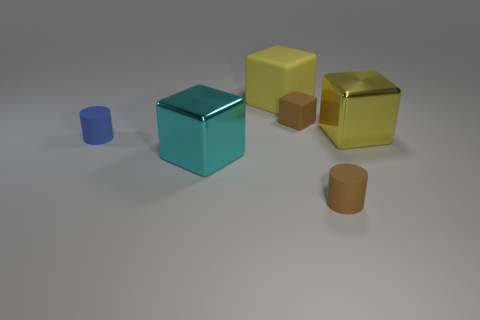Add 2 cubes. How many objects exist? 8 Subtract all cubes. How many objects are left? 2 Add 2 rubber objects. How many rubber objects exist? 6 Subtract 1 brown blocks. How many objects are left? 5 Subtract all small brown cubes. Subtract all yellow shiny things. How many objects are left? 4 Add 3 big matte objects. How many big matte objects are left? 4 